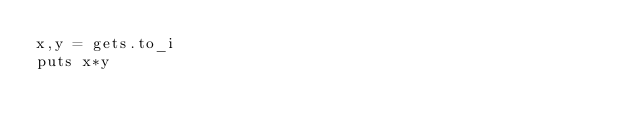Convert code to text. <code><loc_0><loc_0><loc_500><loc_500><_Ruby_>x,y = gets.to_i
puts x*y</code> 